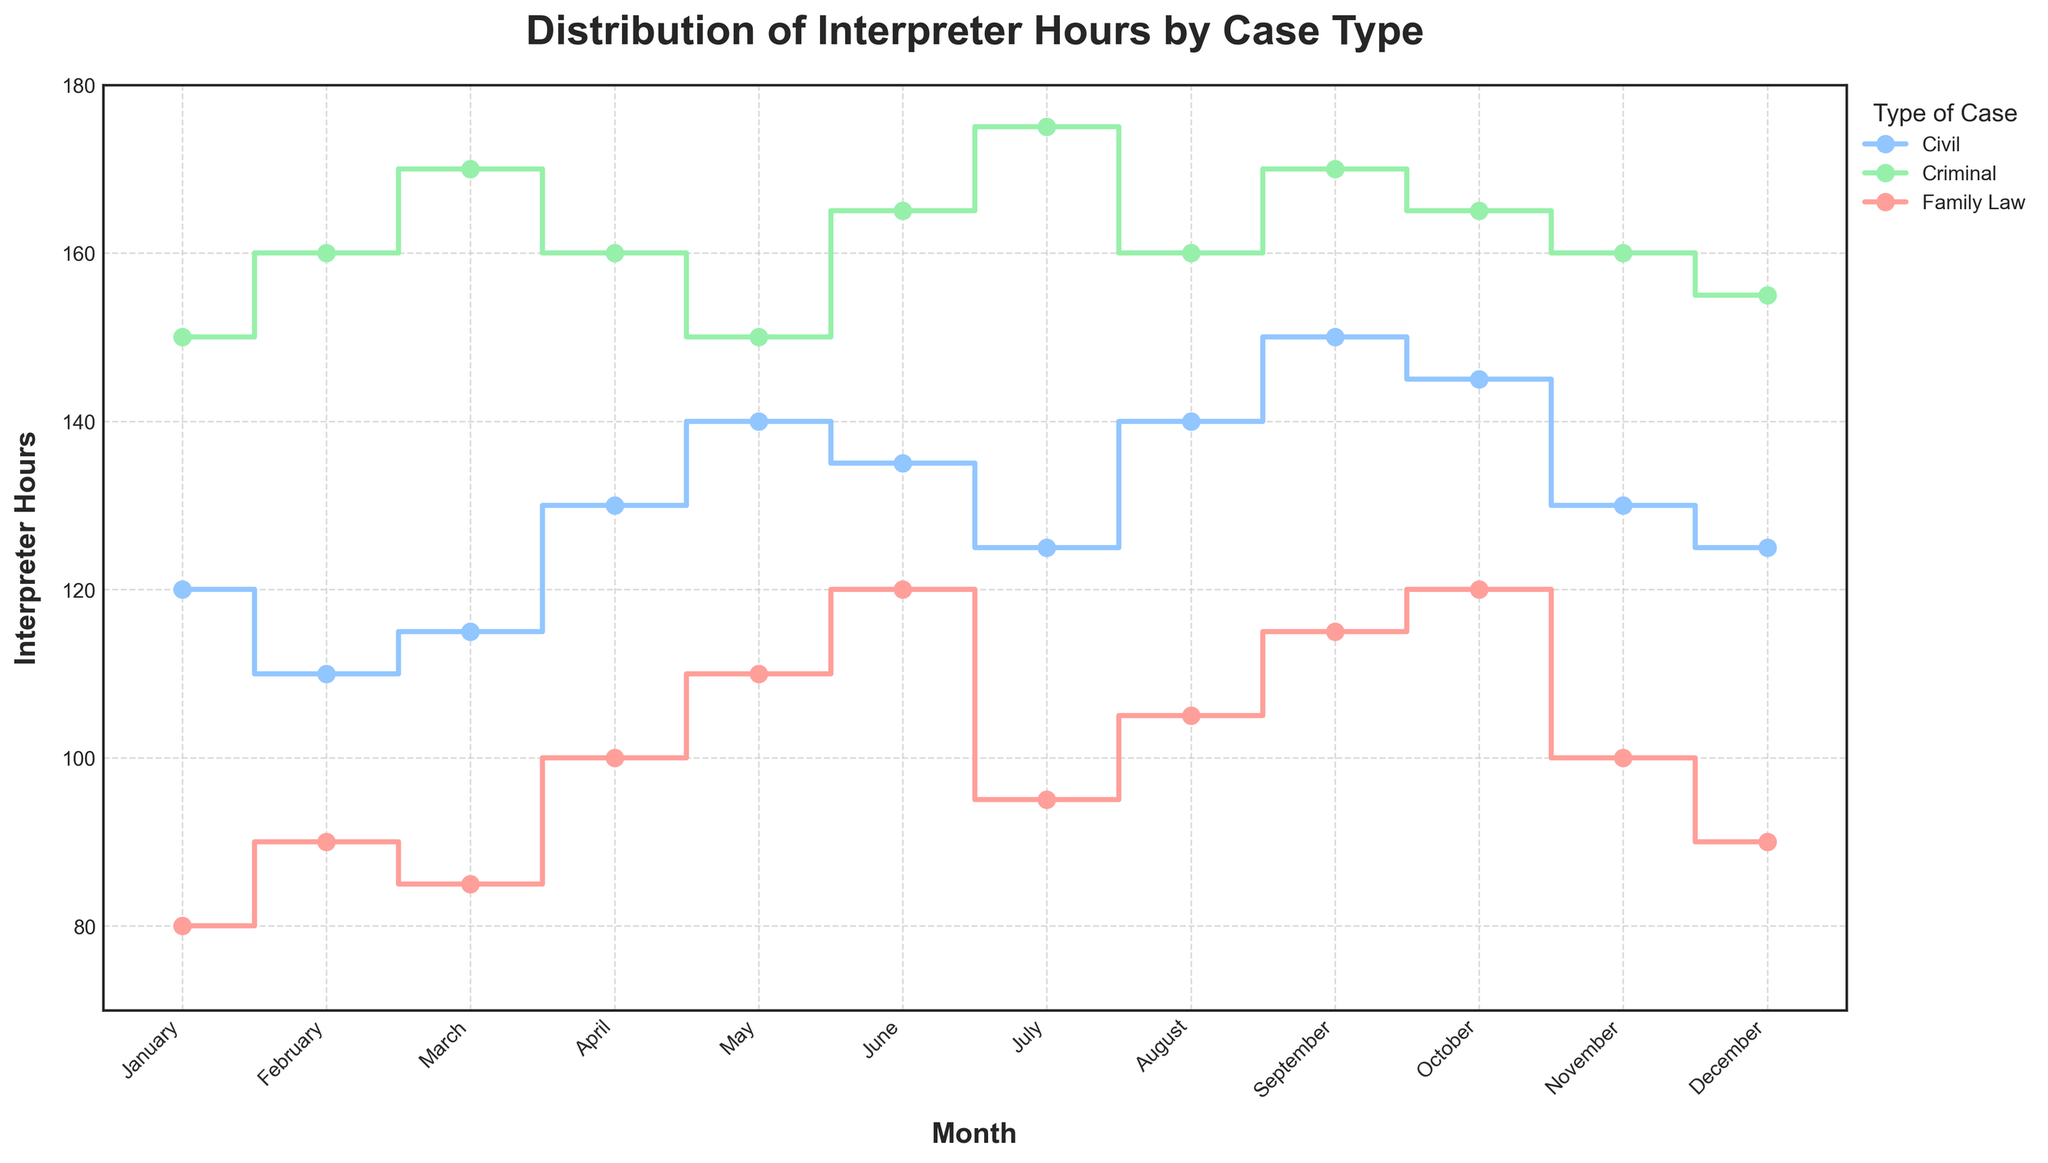What is the title of the figure? The title of the figure is written at the top, in bold.
Answer: Distribution of Interpreter Hours by Case Type Which month shows the most interpreter hours worked in criminal cases? The highest point for the criminal cases line can be identified on the x-axis where its y-value is at the maximum.
Answer: July What is the range of interpreter hours worked in family law cases over the year? To find the range, identify the maximum and minimum interpreter hours for family law cases and subtract the minimum from the maximum. The maximum is 120 in October, and the minimum is 80 in January.
Answer: 40 In which month do civil cases have the highest interpreter hours? Look for the highest point on the civil line throughout the x-axis.
Answer: September What is the difference in interpreter hours between civil and criminal cases in January? Find the values for civil (120) and criminal (150) in January and subtract the civil hours from the criminal hours.
Answer: 30 Are interpreter hours in family law cases generally increasing, decreasing, or staying constant over the year? Trace the line for family law cases across the months to observe the overall trend. The line has some fluctuations but tends to stay around the same values.
Answer: Staying Constant What is the average interpreter hours worked each month for civil cases? Sum the monthly interpreter hours for civil cases and divide by the number of months (12). The total is 1450, so the average is 1450/12.
Answer: Approximately 120.83 Between which months do interpreter hours for criminal cases show a sudden increase? Look for segments on the criminal line where there is a steep upward slope.
Answer: From June to July Which type of case has the least variation in interpreter hours over the year? Compare the variation of interpreter hours for each case type. Family law shows the least variation since its range (40) is smaller compared to civil (40) and criminal (25).
Answer: Family Law How many months have civil interpreter hours worked higher than 130? Count the months where the civil interpreter line is above 130. These months are May, June, August, September, and October, amounting to 5 months.
Answer: 5 